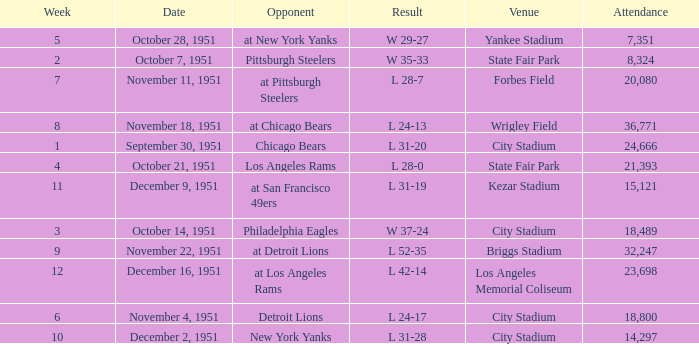Which venue hosted the Los Angeles Rams as an opponent? State Fair Park. 